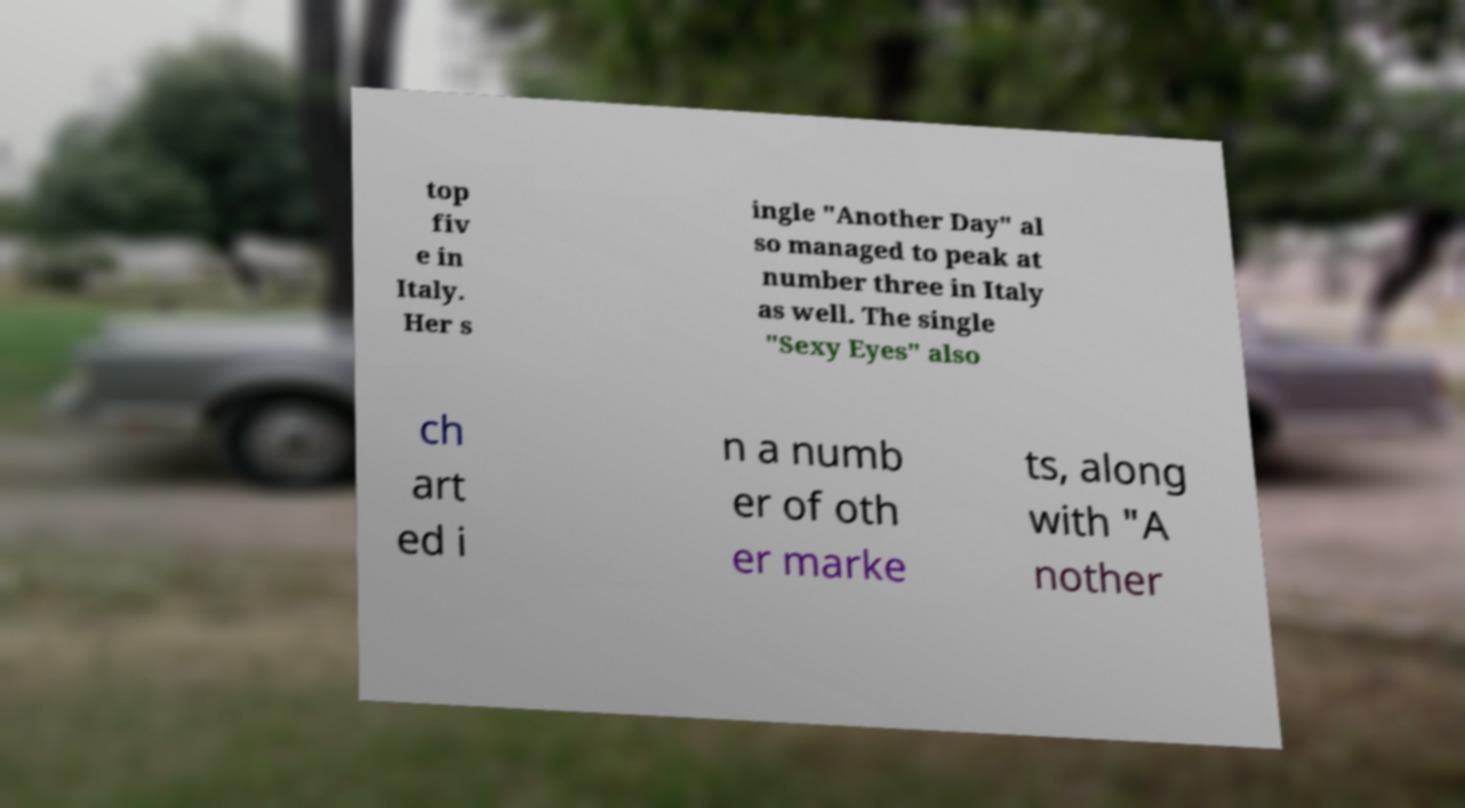For documentation purposes, I need the text within this image transcribed. Could you provide that? top fiv e in Italy. Her s ingle "Another Day" al so managed to peak at number three in Italy as well. The single "Sexy Eyes" also ch art ed i n a numb er of oth er marke ts, along with "A nother 